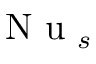Convert formula to latex. <formula><loc_0><loc_0><loc_500><loc_500>N u _ { s }</formula> 